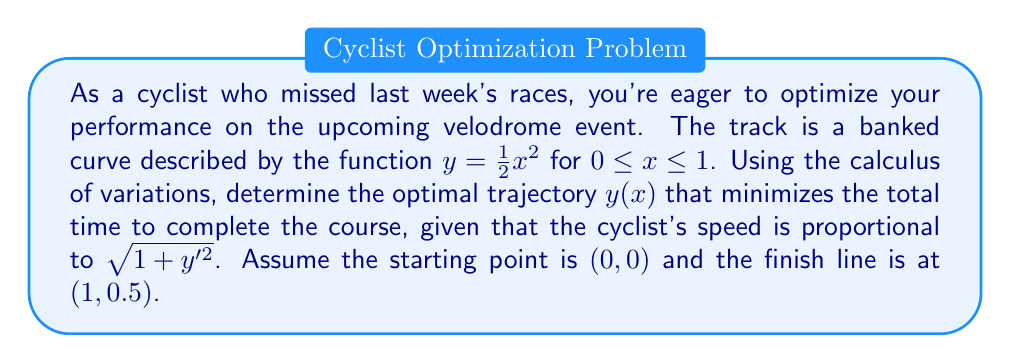Teach me how to tackle this problem. To solve this problem, we'll use the Euler-Lagrange equation from the calculus of variations. Let's break it down step-by-step:

1) The time taken to traverse the curve is given by the integral:

   $$T = \int_0^1 \frac{dx}{v} = \int_0^1 \frac{dx}{k\sqrt{1+y'^2}}$$

   where $k$ is a constant of proportionality.

2) We need to minimize this integral. The integrand is:

   $$F(x,y,y') = \frac{1}{k\sqrt{1+y'^2}}$$

3) The Euler-Lagrange equation is:

   $$\frac{\partial F}{\partial y} - \frac{d}{dx}\left(\frac{\partial F}{\partial y'}\right) = 0$$

4) We have:
   
   $$\frac{\partial F}{\partial y} = 0$$
   
   $$\frac{\partial F}{\partial y'} = -\frac{y'}{k(1+y'^2)^{3/2}}$$

5) Substituting into the Euler-Lagrange equation:

   $$\frac{d}{dx}\left(\frac{y'}{(1+y'^2)^{3/2}}\right) = 0$$

6) This implies:

   $$\frac{y'}{(1+y'^2)^{3/2}} = C$$ (constant)

7) Solving this differential equation:

   $$y' = \frac{C}{\sqrt{1-C^2x^2}}$$

8) Integrating:

   $$y = \frac{1}{C}\sqrt{1-C^2x^2} + D$$

9) Using the boundary conditions $y(0) = 0$ and $y(1) = 0.5$, we can determine $C$ and $D$:

   $$D = -\frac{1}{C}$$
   $$0.5 = \frac{1}{C}(\sqrt{1-C^2} - 1)$$

10) Solving numerically, we get $C \approx 0.7698$ and $D \approx -1.2989$.

Therefore, the optimal trajectory is:

$$y(x) = \frac{1}{0.7698}\sqrt{1-0.7698^2x^2} - 1.2989$$
Answer: The optimal trajectory for the cyclist is given by:

$$y(x) = \frac{1}{0.7698}\sqrt{1-0.7698^2x^2} - 1.2989$$

where $0 \leq x \leq 1$. 